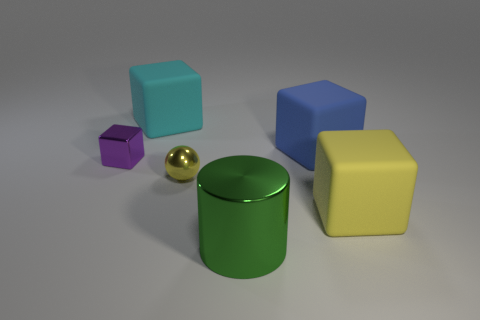Do the green cylinder and the blue block have the same size?
Provide a succinct answer. Yes. There is a thing that is the same color as the metallic ball; what is its material?
Your response must be concise. Rubber. There is a big rubber object that is behind the yellow metallic sphere and in front of the big cyan rubber block; what shape is it?
Your answer should be compact. Cube. How many other blue objects are the same material as the blue thing?
Your answer should be compact. 0. Is the number of small yellow balls that are left of the yellow metallic thing less than the number of cubes that are behind the green metal object?
Give a very brief answer. Yes. The yellow thing behind the big yellow matte object that is in front of the yellow object left of the large yellow cube is made of what material?
Offer a very short reply. Metal. What is the size of the shiny object that is behind the green cylinder and right of the cyan rubber thing?
Your answer should be compact. Small. What number of cylinders are either large green metallic things or large objects?
Your answer should be very brief. 1. The metal object that is the same size as the blue matte object is what color?
Your answer should be very brief. Green. Is there anything else that is the same shape as the large metallic thing?
Your answer should be very brief. No. 